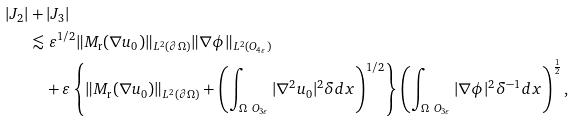<formula> <loc_0><loc_0><loc_500><loc_500>| J _ { 2 } | & + | J _ { 3 } | \\ & \lesssim \varepsilon ^ { 1 / 2 } \| M _ { \text {r} } ( \nabla u _ { 0 } ) \| _ { L ^ { 2 } ( \partial \Omega ) } \| \nabla \phi \| _ { L ^ { 2 } ( O _ { 4 \varepsilon } ) } \\ & \quad + \varepsilon \left \{ \| M _ { \text {r} } ( \nabla u _ { 0 } ) \| _ { L ^ { 2 } ( \partial \Omega ) } + \left ( \int _ { \Omega \ O _ { 3 \varepsilon } } | \nabla ^ { 2 } u _ { 0 } | ^ { 2 } \delta d x \right ) ^ { 1 / 2 } \right \} \left ( \int _ { \Omega \ O _ { 3 \varepsilon } } | \nabla \phi | ^ { 2 } \delta ^ { - 1 } d x \right ) ^ { \frac { 1 } { 2 } } ,</formula> 